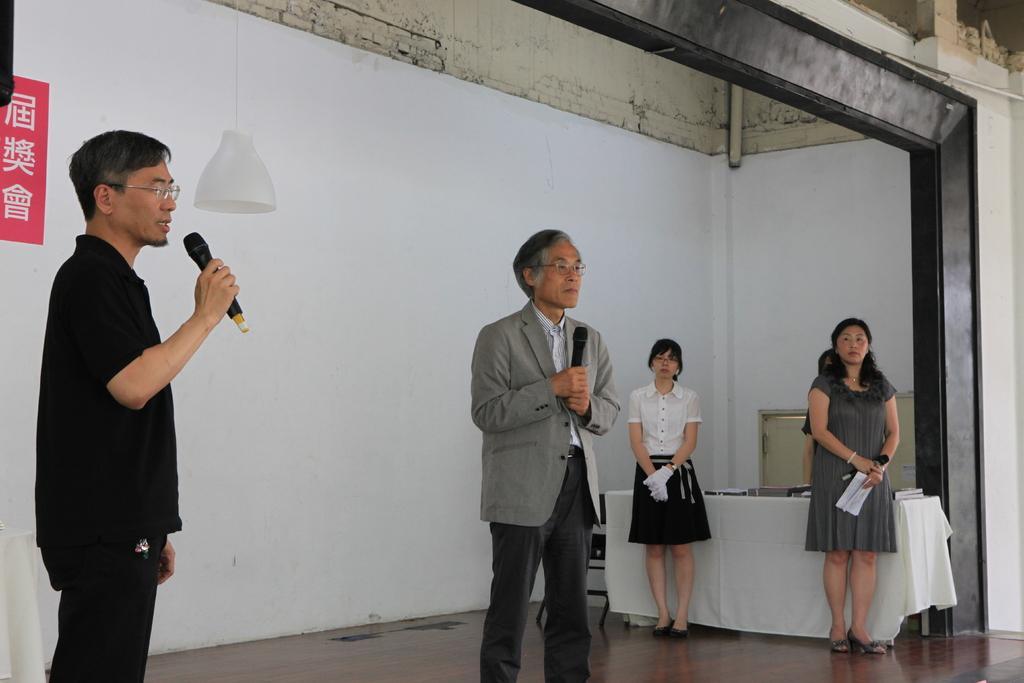Could you give a brief overview of what you see in this image? In the foreground of this image, there two men and a woman standing and holding a mic. Behind them, there is a woman standing near a table on which there are books like objects. At the top, there is a lamp hanging and we can also see the wall. 